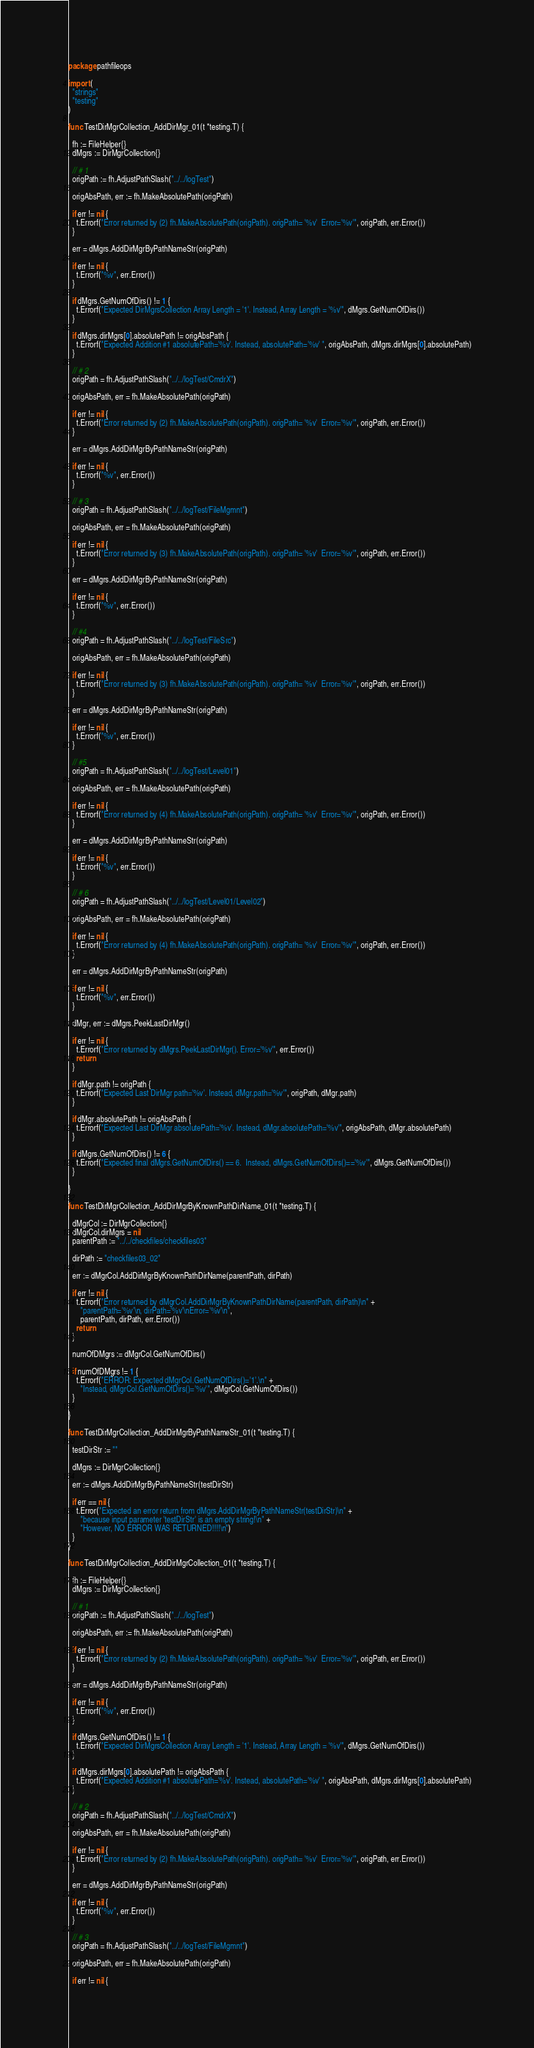<code> <loc_0><loc_0><loc_500><loc_500><_Go_>package pathfileops

import (
  "strings"
  "testing"
)

func TestDirMgrCollection_AddDirMgr_01(t *testing.T) {

  fh := FileHelper{}
  dMgrs := DirMgrCollection{}

  // # 1
  origPath := fh.AdjustPathSlash("../../logTest")

  origAbsPath, err := fh.MakeAbsolutePath(origPath)

  if err != nil {
    t.Errorf("Error returned by (2) fh.MakeAbsolutePath(origPath). origPath= '%v'  Error='%v'", origPath, err.Error())
  }

  err = dMgrs.AddDirMgrByPathNameStr(origPath)

  if err != nil {
    t.Errorf("%v", err.Error())
  }

  if dMgrs.GetNumOfDirs() != 1 {
    t.Errorf("Expected DirMgrsCollection Array Length = '1'. Instead, Array Length = '%v'", dMgrs.GetNumOfDirs())
  }

  if dMgrs.dirMgrs[0].absolutePath != origAbsPath {
    t.Errorf("Expected Addition #1 absolutePath='%v'. Instead, absolutePath='%v' ", origAbsPath, dMgrs.dirMgrs[0].absolutePath)
  }

  // # 2
  origPath = fh.AdjustPathSlash("../../logTest/CmdrX")

  origAbsPath, err = fh.MakeAbsolutePath(origPath)

  if err != nil {
    t.Errorf("Error returned by (2) fh.MakeAbsolutePath(origPath). origPath= '%v'  Error='%v'", origPath, err.Error())
  }

  err = dMgrs.AddDirMgrByPathNameStr(origPath)

  if err != nil {
    t.Errorf("%v", err.Error())
  }

  // # 3
  origPath = fh.AdjustPathSlash("../../logTest/FileMgmnt")

  origAbsPath, err = fh.MakeAbsolutePath(origPath)

  if err != nil {
    t.Errorf("Error returned by (3) fh.MakeAbsolutePath(origPath). origPath= '%v'  Error='%v'", origPath, err.Error())
  }

  err = dMgrs.AddDirMgrByPathNameStr(origPath)

  if err != nil {
    t.Errorf("%v", err.Error())
  }

  // #4
  origPath = fh.AdjustPathSlash("../../logTest/FileSrc")

  origAbsPath, err = fh.MakeAbsolutePath(origPath)

  if err != nil {
    t.Errorf("Error returned by (3) fh.MakeAbsolutePath(origPath). origPath= '%v'  Error='%v'", origPath, err.Error())
  }

  err = dMgrs.AddDirMgrByPathNameStr(origPath)

  if err != nil {
    t.Errorf("%v", err.Error())
  }

  // #5
  origPath = fh.AdjustPathSlash("../../logTest/Level01")

  origAbsPath, err = fh.MakeAbsolutePath(origPath)

  if err != nil {
    t.Errorf("Error returned by (4) fh.MakeAbsolutePath(origPath). origPath= '%v'  Error='%v'", origPath, err.Error())
  }

  err = dMgrs.AddDirMgrByPathNameStr(origPath)

  if err != nil {
    t.Errorf("%v", err.Error())
  }

  // # 6
  origPath = fh.AdjustPathSlash("../../logTest/Level01/Level02")

  origAbsPath, err = fh.MakeAbsolutePath(origPath)

  if err != nil {
    t.Errorf("Error returned by (4) fh.MakeAbsolutePath(origPath). origPath= '%v'  Error='%v'", origPath, err.Error())
  }

  err = dMgrs.AddDirMgrByPathNameStr(origPath)

  if err != nil {
    t.Errorf("%v", err.Error())
  }

  dMgr, err := dMgrs.PeekLastDirMgr()

  if err != nil {
    t.Errorf("Error returned by dMgrs.PeekLastDirMgr(). Error='%v'", err.Error())
    return
  }

  if dMgr.path != origPath {
    t.Errorf("Expected Last DirMgr path='%v'. Instead, dMgr.path='%v'", origPath, dMgr.path)
  }

  if dMgr.absolutePath != origAbsPath {
    t.Errorf("Expected Last DirMgr absolutePath='%v'. Instead, dMgr.absolutePath='%v'", origAbsPath, dMgr.absolutePath)
  }

  if dMgrs.GetNumOfDirs() != 6 {
    t.Errorf("Expected final dMgrs.GetNumOfDirs() == 6.  Instead, dMgrs.GetNumOfDirs()=='%v'", dMgrs.GetNumOfDirs())
  }

}

func TestDirMgrCollection_AddDirMgrByKnownPathDirName_01(t *testing.T) {

  dMgrCol := DirMgrCollection{}
  dMgrCol.dirMgrs = nil
  parentPath := "../../checkfiles/checkfiles03"

  dirPath := "checkfiles03_02"

  err := dMgrCol.AddDirMgrByKnownPathDirName(parentPath, dirPath)

  if err != nil {
    t.Errorf("Error returned by dMgrCol.AddDirMgrByKnownPathDirName(parentPath, dirPath)\n" +
      "parentPath='%v'\n, dirPath='%v'\nError='%v'\n",
      parentPath, dirPath, err.Error())
    return
  }

  numOfDMgrs := dMgrCol.GetNumOfDirs()

  if numOfDMgrs != 1 {
    t.Errorf("ERROR: Expected dMgrCol.GetNumOfDirs()='1'.\n" +
      "Instead, dMgrCol.GetNumOfDirs()='%v'", dMgrCol.GetNumOfDirs())
  }

}

func TestDirMgrCollection_AddDirMgrByPathNameStr_01(t *testing.T) {

  testDirStr := ""

  dMgrs := DirMgrCollection{}

  err := dMgrs.AddDirMgrByPathNameStr(testDirStr)

  if err == nil {
    t.Error("Expected an error return from dMgrs.AddDirMgrByPathNameStr(testDirStr)\n" +
      "because input parameter 'testDirStr' is an empty string!\n" +
      "However, NO ERROR WAS RETURNED!!!!\n")
  }
}

func TestDirMgrCollection_AddDirMgrCollection_01(t *testing.T) {

  fh := FileHelper{}
  dMgrs := DirMgrCollection{}

  // # 1
  origPath := fh.AdjustPathSlash("../../logTest")

  origAbsPath, err := fh.MakeAbsolutePath(origPath)

  if err != nil {
    t.Errorf("Error returned by (2) fh.MakeAbsolutePath(origPath). origPath= '%v'  Error='%v'", origPath, err.Error())
  }

  err = dMgrs.AddDirMgrByPathNameStr(origPath)

  if err != nil {
    t.Errorf("%v", err.Error())
  }

  if dMgrs.GetNumOfDirs() != 1 {
    t.Errorf("Expected DirMgrsCollection Array Length = '1'. Instead, Array Length = '%v'", dMgrs.GetNumOfDirs())
  }

  if dMgrs.dirMgrs[0].absolutePath != origAbsPath {
    t.Errorf("Expected Addition #1 absolutePath='%v'. Instead, absolutePath='%v' ", origAbsPath, dMgrs.dirMgrs[0].absolutePath)
  }

  // # 2
  origPath = fh.AdjustPathSlash("../../logTest/CmdrX")

  origAbsPath, err = fh.MakeAbsolutePath(origPath)

  if err != nil {
    t.Errorf("Error returned by (2) fh.MakeAbsolutePath(origPath). origPath= '%v'  Error='%v'", origPath, err.Error())
  }

  err = dMgrs.AddDirMgrByPathNameStr(origPath)

  if err != nil {
    t.Errorf("%v", err.Error())
  }

  // # 3
  origPath = fh.AdjustPathSlash("../../logTest/FileMgmnt")

  origAbsPath, err = fh.MakeAbsolutePath(origPath)

  if err != nil {</code> 